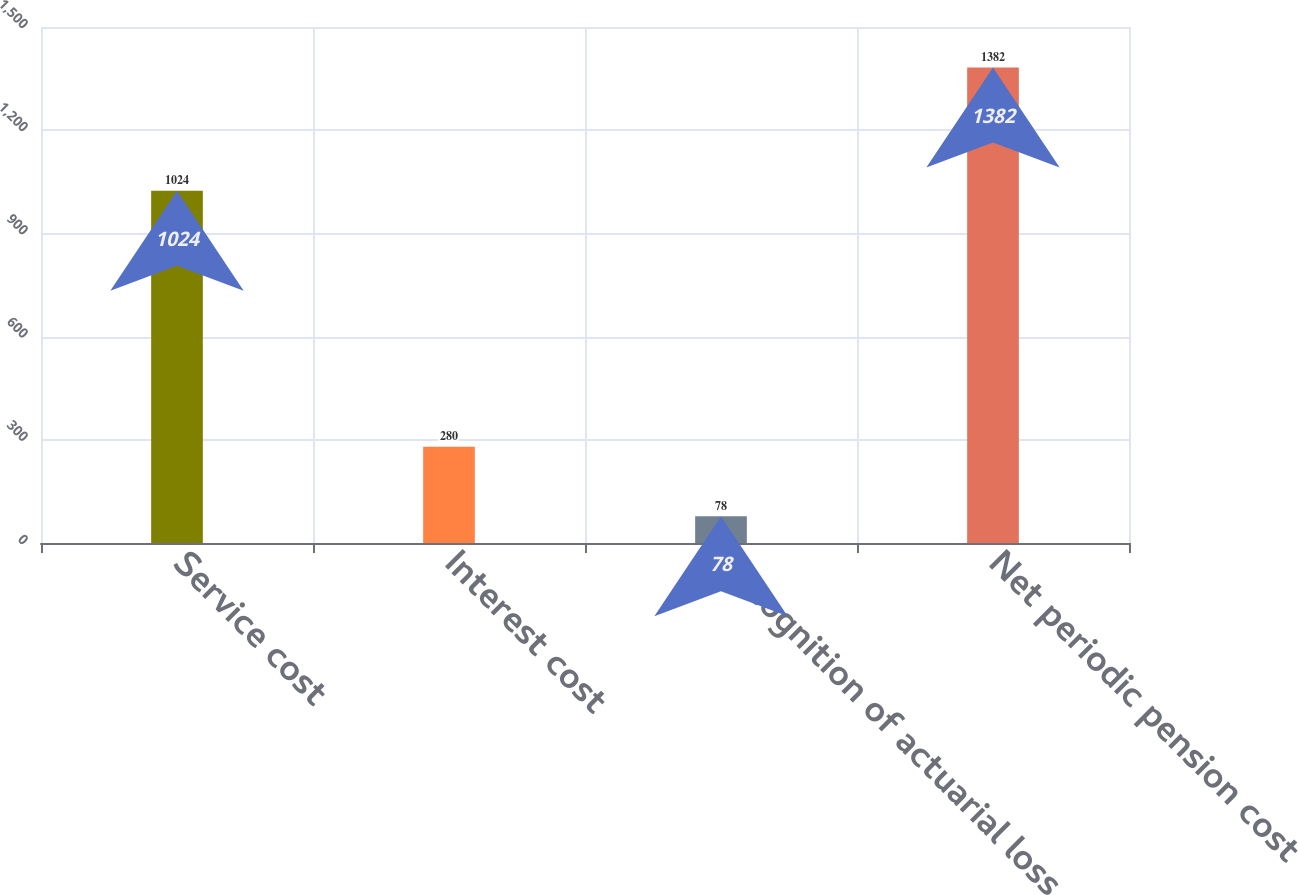Convert chart to OTSL. <chart><loc_0><loc_0><loc_500><loc_500><bar_chart><fcel>Service cost<fcel>Interest cost<fcel>Recognition of actuarial loss<fcel>Net periodic pension cost<nl><fcel>1024<fcel>280<fcel>78<fcel>1382<nl></chart> 